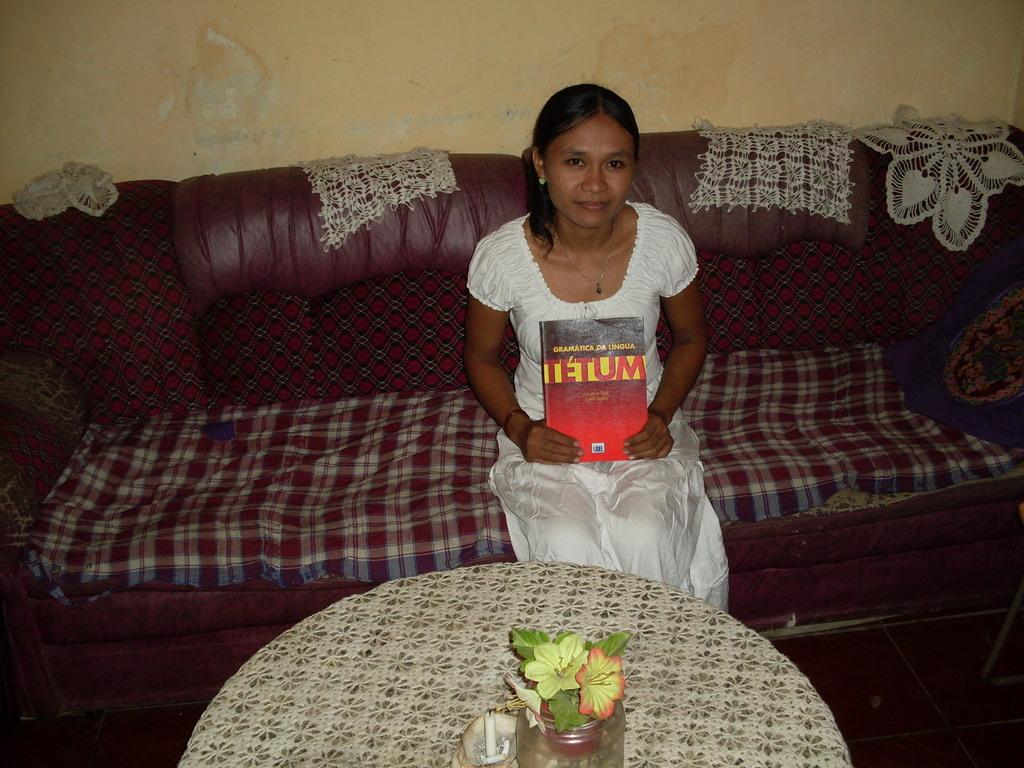Who is present in the image? There is a woman in the image. What is the woman doing in the image? The woman is sitting on a sofa. What is the woman holding in the image? The woman is holding a book. What is on the table in front of the woman? There is a flower vase and a candle on the table. What can be seen in the background of the image? There is a wall in the background of the image. What type of toothpaste is the woman using in the image? There is no toothpaste present in the image. What color is the woman's underwear in the image? There is no underwear visible in the image. 